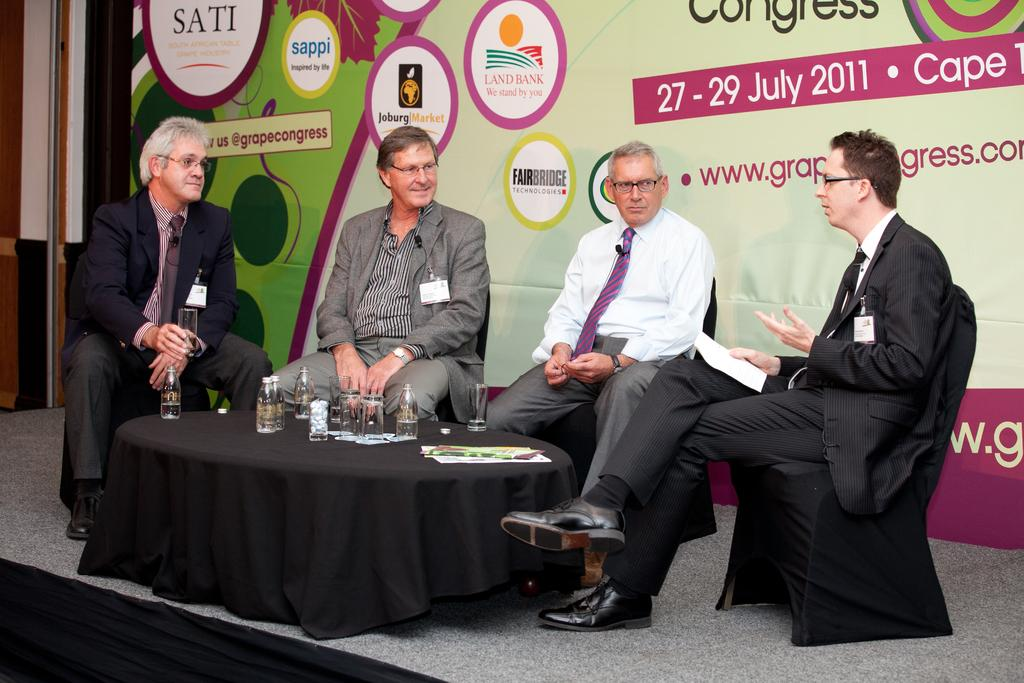How many people are present in the image? There are four people in the image. What are the people doing in the image? The people are seated on chairs and speaking with each other. What level of peace is being discussed by the people in the image? There is no indication in the image of what level of peace is being discussed, as the conversation is not audible or visible. 